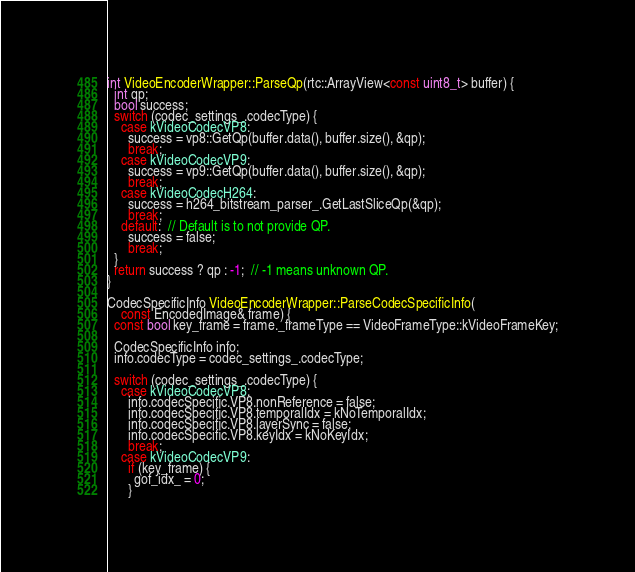Convert code to text. <code><loc_0><loc_0><loc_500><loc_500><_C++_>
int VideoEncoderWrapper::ParseQp(rtc::ArrayView<const uint8_t> buffer) {
  int qp;
  bool success;
  switch (codec_settings_.codecType) {
    case kVideoCodecVP8:
      success = vp8::GetQp(buffer.data(), buffer.size(), &qp);
      break;
    case kVideoCodecVP9:
      success = vp9::GetQp(buffer.data(), buffer.size(), &qp);
      break;
    case kVideoCodecH264:
      success = h264_bitstream_parser_.GetLastSliceQp(&qp);
      break;
    default:  // Default is to not provide QP.
      success = false;
      break;
  }
  return success ? qp : -1;  // -1 means unknown QP.
}

CodecSpecificInfo VideoEncoderWrapper::ParseCodecSpecificInfo(
    const EncodedImage& frame) {
  const bool key_frame = frame._frameType == VideoFrameType::kVideoFrameKey;

  CodecSpecificInfo info;
  info.codecType = codec_settings_.codecType;

  switch (codec_settings_.codecType) {
    case kVideoCodecVP8:
      info.codecSpecific.VP8.nonReference = false;
      info.codecSpecific.VP8.temporalIdx = kNoTemporalIdx;
      info.codecSpecific.VP8.layerSync = false;
      info.codecSpecific.VP8.keyIdx = kNoKeyIdx;
      break;
    case kVideoCodecVP9:
      if (key_frame) {
        gof_idx_ = 0;
      }</code> 